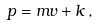<formula> <loc_0><loc_0><loc_500><loc_500>p = m v + k \, ,</formula> 